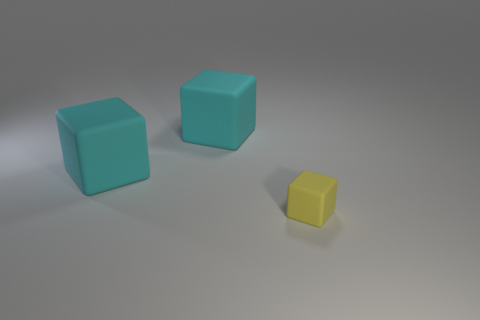Subtract all small matte cubes. How many cubes are left? 2 Subtract all cyan blocks. How many blocks are left? 1 Add 1 big cyan cubes. How many objects exist? 4 Subtract 1 blocks. How many blocks are left? 2 Subtract all green cubes. Subtract all blue balls. How many cubes are left? 3 Subtract all red spheres. How many yellow cubes are left? 1 Subtract all small green rubber blocks. Subtract all large cubes. How many objects are left? 1 Add 1 tiny blocks. How many tiny blocks are left? 2 Add 2 large purple cylinders. How many large purple cylinders exist? 2 Subtract 0 purple cubes. How many objects are left? 3 